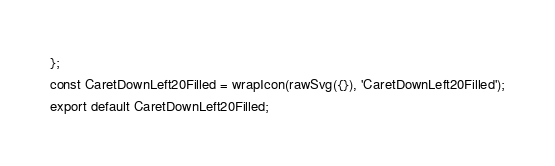Convert code to text. <code><loc_0><loc_0><loc_500><loc_500><_JavaScript_>};
const CaretDownLeft20Filled = wrapIcon(rawSvg({}), 'CaretDownLeft20Filled');
export default CaretDownLeft20Filled;
</code> 